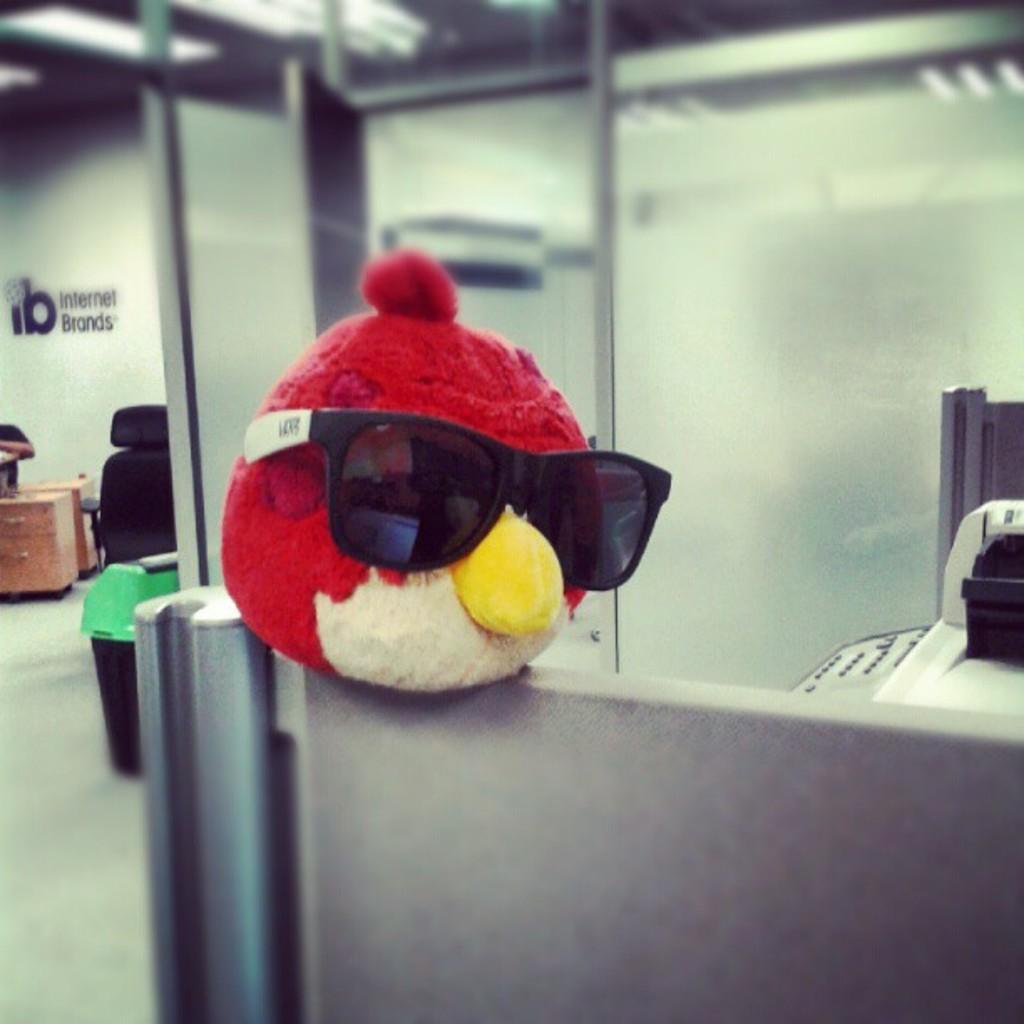Could you give a brief overview of what you see in this image? In the center of the picture there is an angry bird toy with spectacles on it. On the right there is a xerox machine and a cabin. In the center of the picture there is a glass window. On the left there are desk, chair, dustbin and wall. At the top there are lights. 